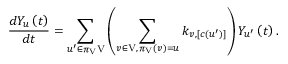<formula> <loc_0><loc_0><loc_500><loc_500>\frac { d Y _ { u } \left ( t \right ) } { d t } = \sum _ { u ^ { \prime } \in \pi _ { V } V } \left ( \sum _ { \substack { v \in V , \, \pi _ { V } \left ( v \right ) = u } } k _ { v , \left [ c \left ( u ^ { \prime } \right ) \right ] } \right ) Y _ { u ^ { \prime } } \left ( t \right ) .</formula> 